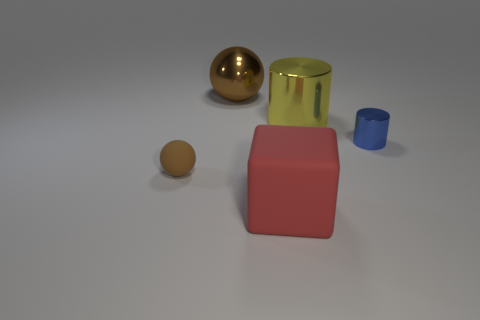Add 5 small blue matte things. How many objects exist? 10 Subtract all cubes. How many objects are left? 4 Subtract all small green rubber cylinders. Subtract all tiny metallic objects. How many objects are left? 4 Add 4 yellow things. How many yellow things are left? 5 Add 5 purple metal spheres. How many purple metal spheres exist? 5 Subtract 0 purple spheres. How many objects are left? 5 